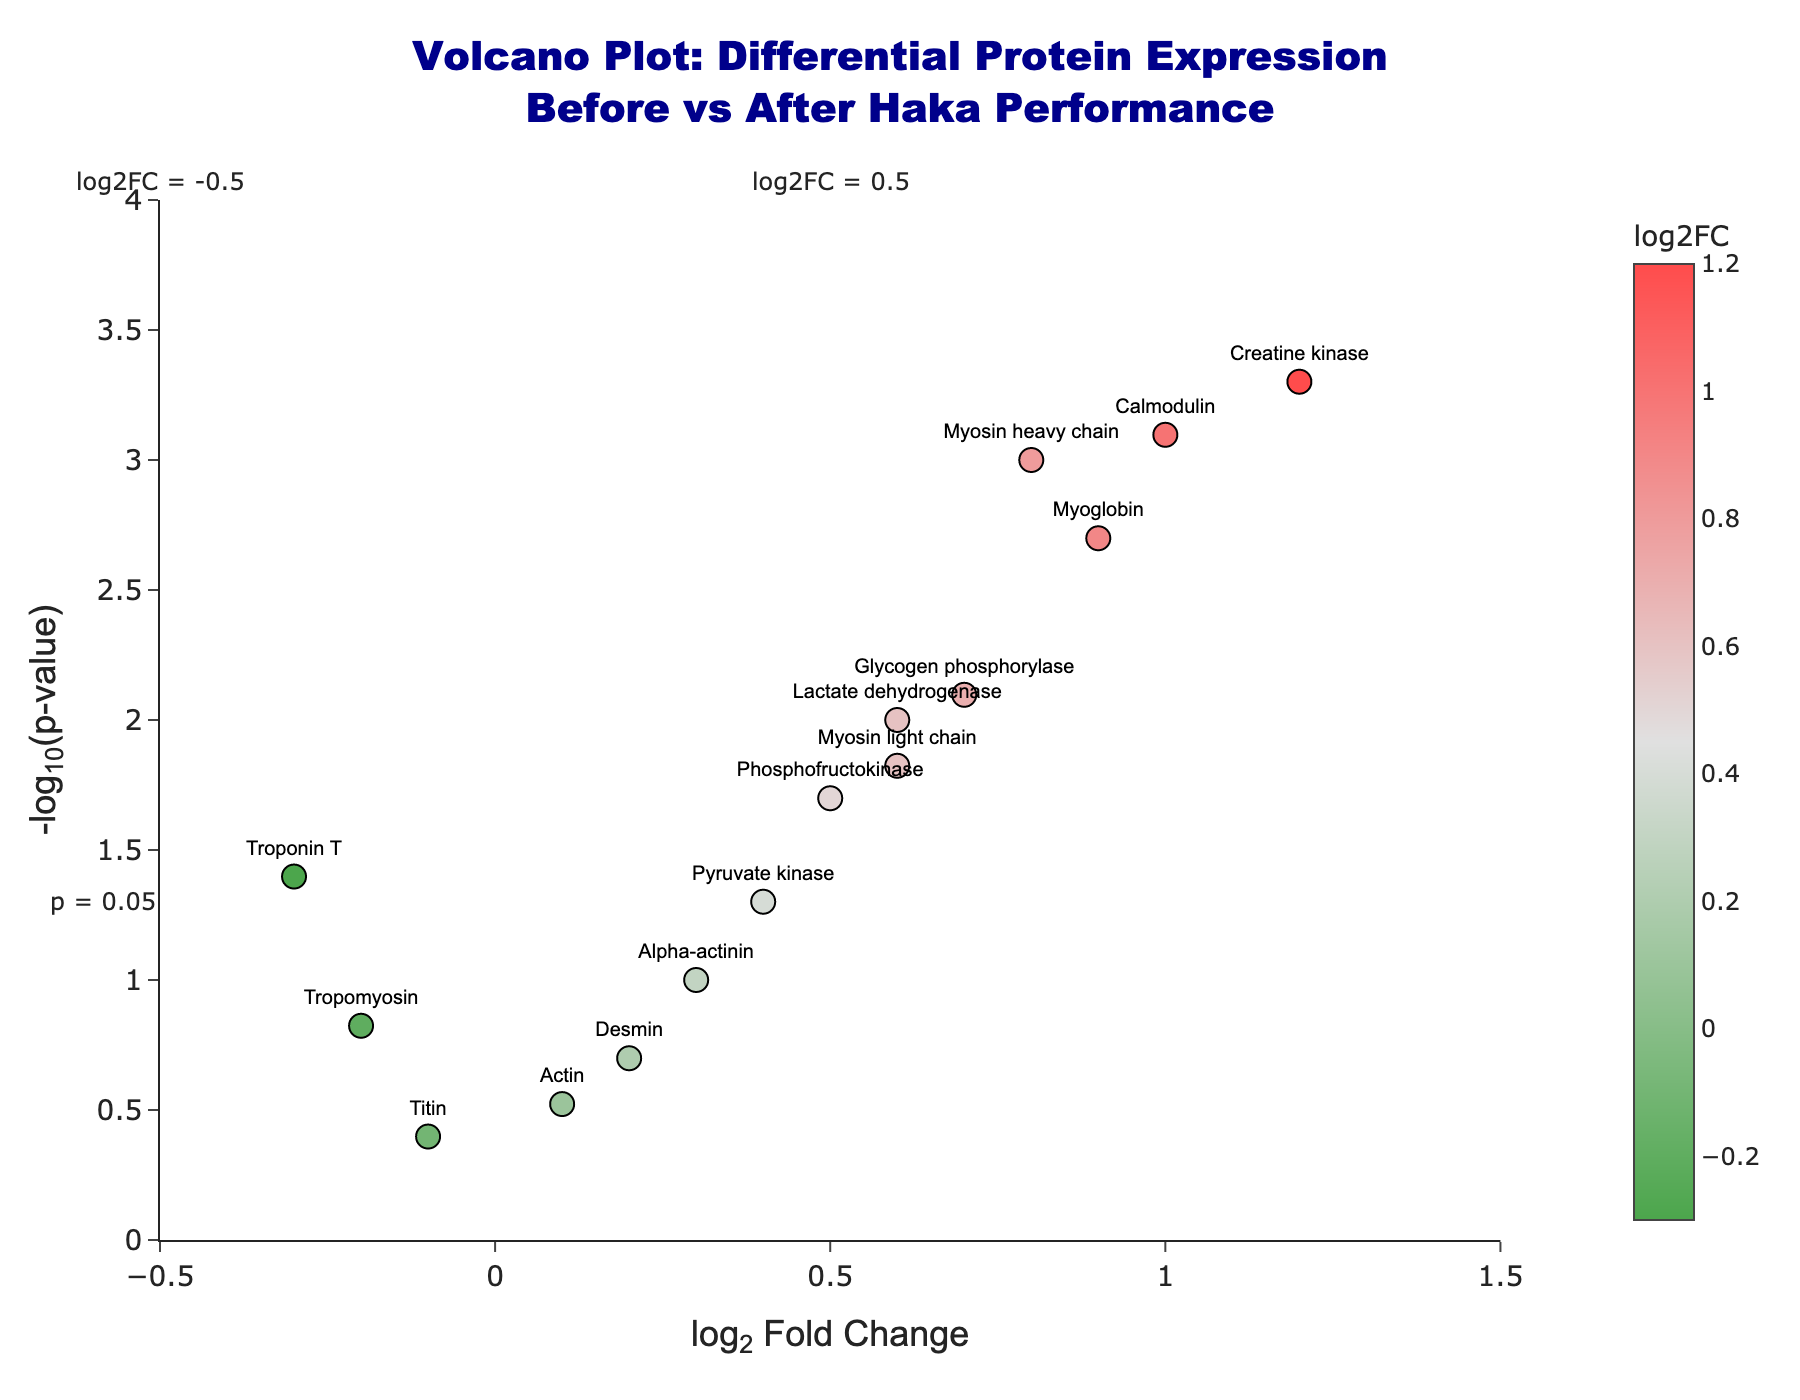What is the title of the figure? The title is usually displayed at the top of the figure. The figure title here is "Volcano Plot: Differential Protein Expression Before vs After Haka Performance".
Answer: Volcano Plot: Differential Protein Expression Before vs After Haka Performance What information is displayed on the x-axis? The x-axis in the figure shows the "log2 Fold Change", indicating how much the expression levels of proteins have changed after performing the haka.
Answer: log2 Fold Change How many proteins have a p-value lower than 0.05? To determine this, count the number of data points above the horizontal line at -log10(0.05), which is roughly around 1.3 on the y-axis. There are 10 proteins satisfying this condition.
Answer: 10 Which protein has the highest log2 fold change? To identify this, look for the data point furthest to the right on the x-axis. The protein with the highest log2 fold change is "Creatine kinase" with a value of 1.2.
Answer: Creatine kinase Which proteins have both a log2 fold change greater than 0.5 and a p-value less than 0.05? To find these proteins, look for data points to the right of the vertical line at log2FC = 0.5 and above the horizontal line at -log10(0.05). The proteins that meet these criteria are "Myosin heavy chain", "Creatine kinase", "Lactate dehydrogenase", "Myoglobin", "Glycogen phosphorylase", "Phosphofructokinase", "Calmodulin", and "Myosin light chain".
Answer: Myosin heavy chain, Creatine kinase, Lactate dehydrogenase, Myoglobin, Glycogen phosphorylase, Phosphofructokinase, Calmodulin, Myosin light chain Which protein has the lowest -log10(p-value)? The -log10(p-value) is lowest for the point closest to the x-axis (lowest y-value). That protein is "Titin".
Answer: Titin Compare the positions of "Myosin heavy chain" and "Troponin T" on the plot. Which protein shows a greater change in expression levels? "Myosin heavy chain" has a log2 fold change of 0.8, while "Troponin T" has a log2 fold change of -0.3. The magnitude of change for "Myosin heavy chain" is greater.
Answer: Myosin heavy chain What does a point with a positive log2 fold change and high -log10(p-value) signify in this plot? A point with a positive log2 fold change indicates increased expression after the haka, and a high -log10(p-value) represents statistical significance, meaning this increase is reliable.
Answer: Increased expression and statistical significance 